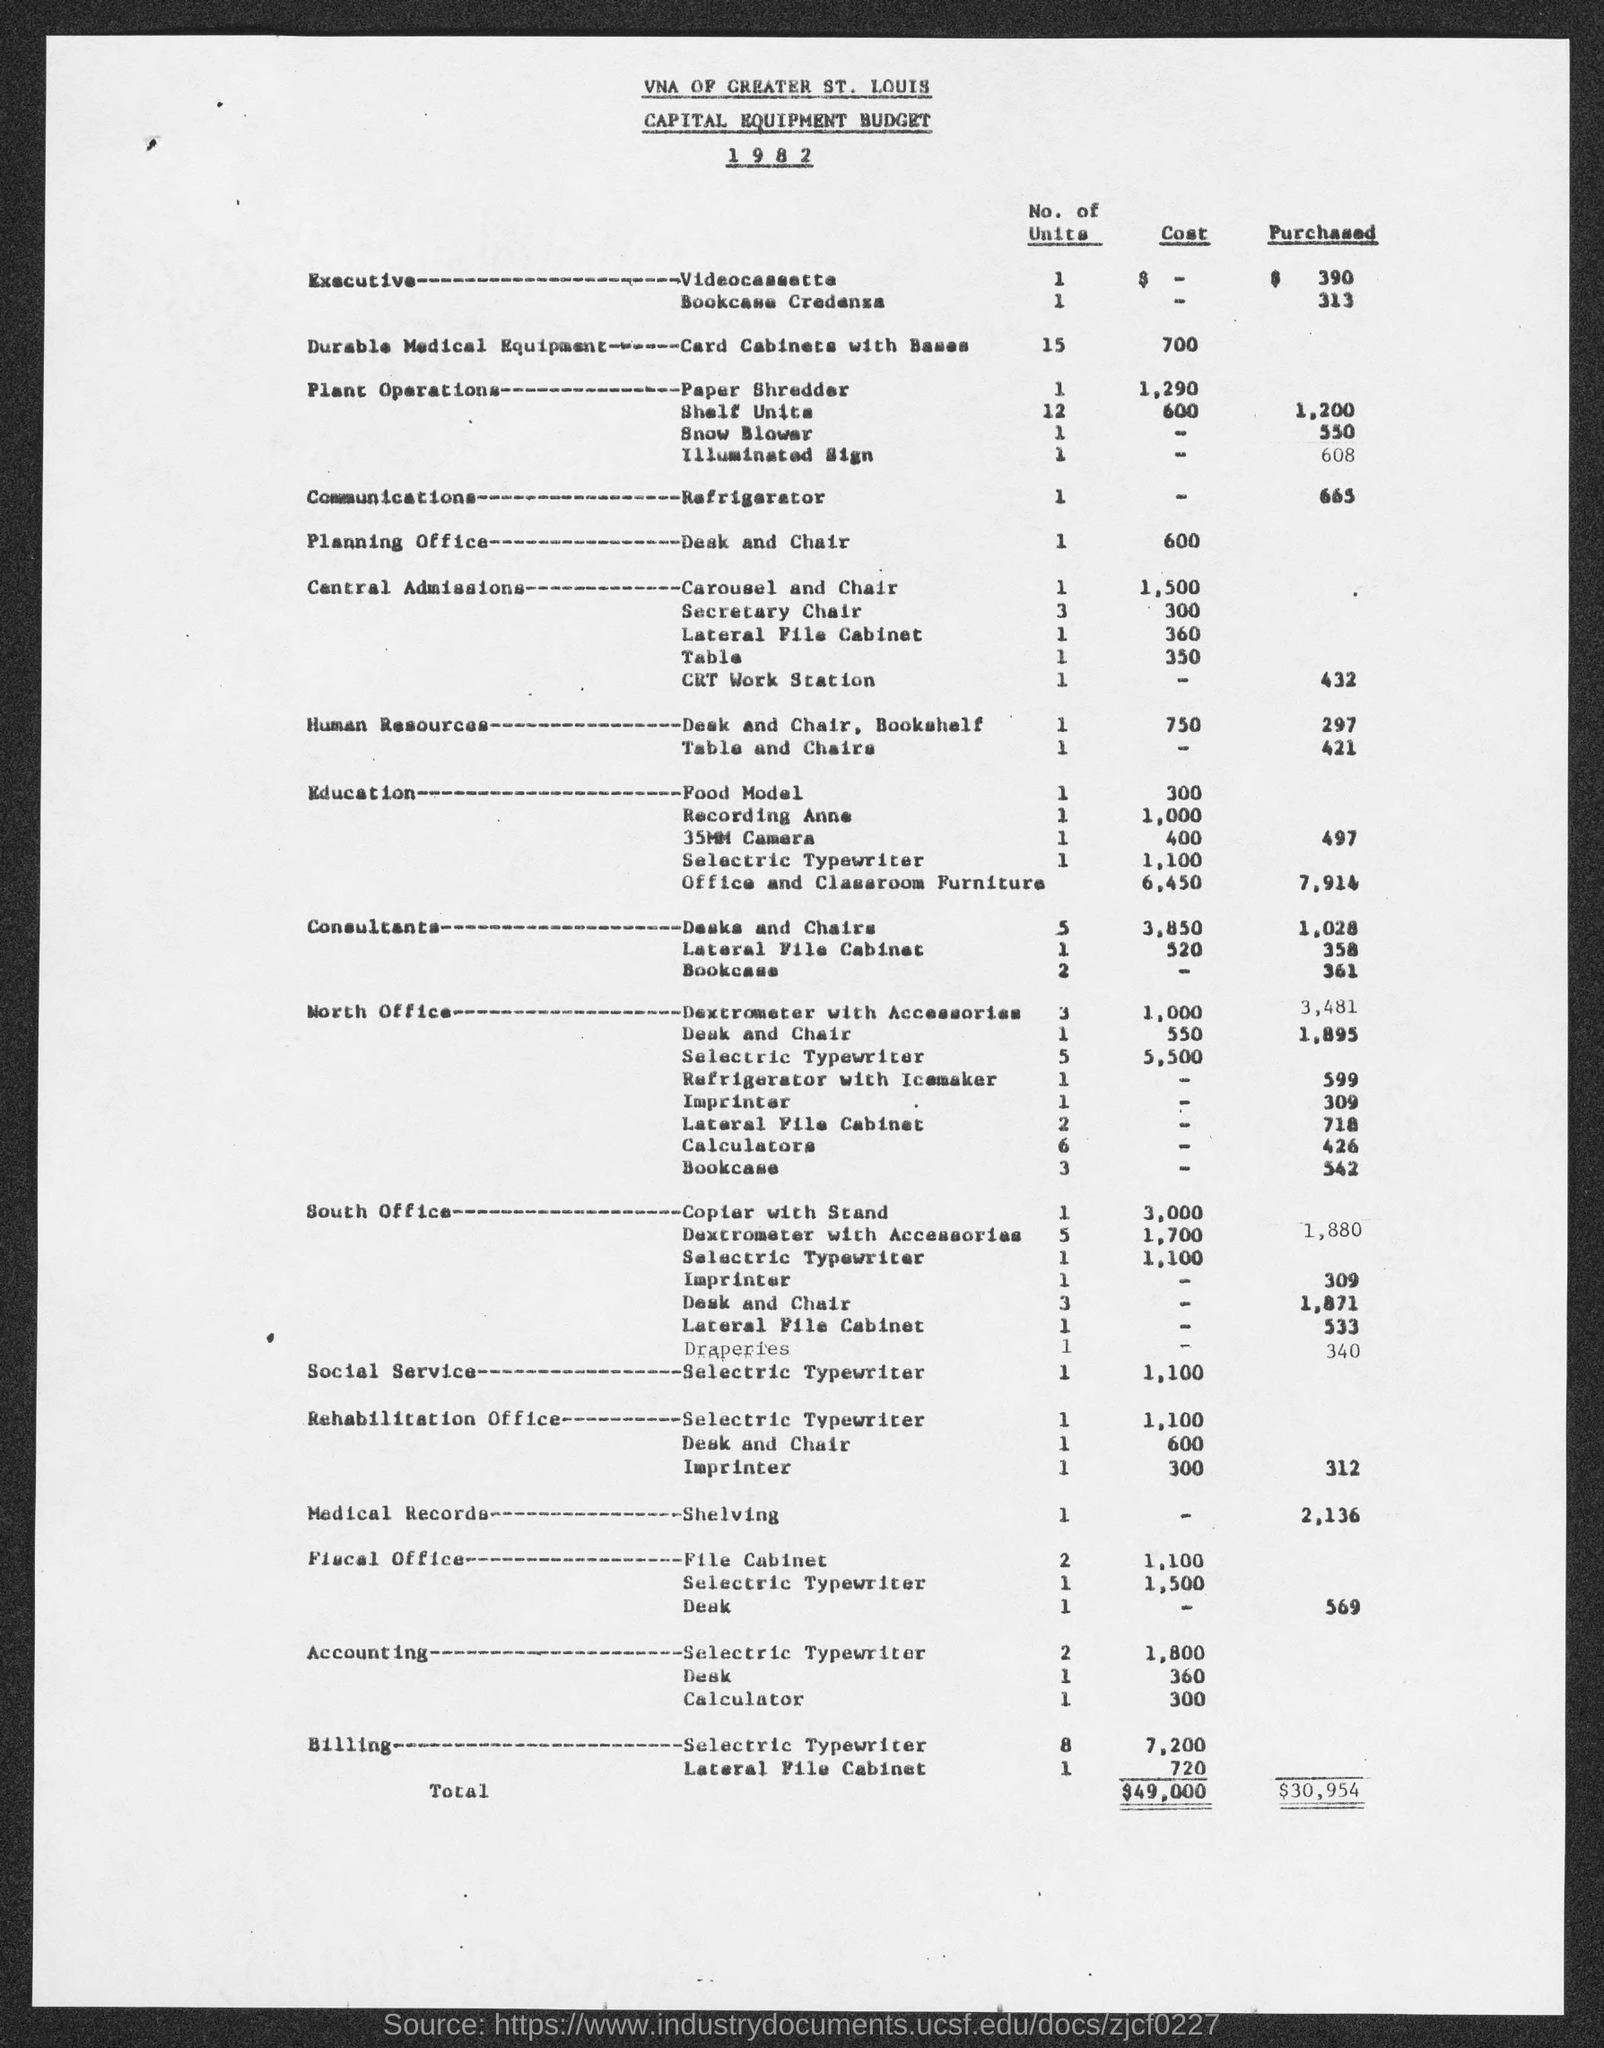For which year is the budget?
Provide a succinct answer. 1982. What is the document about?
Offer a terse response. Capital Equipment Budget. 